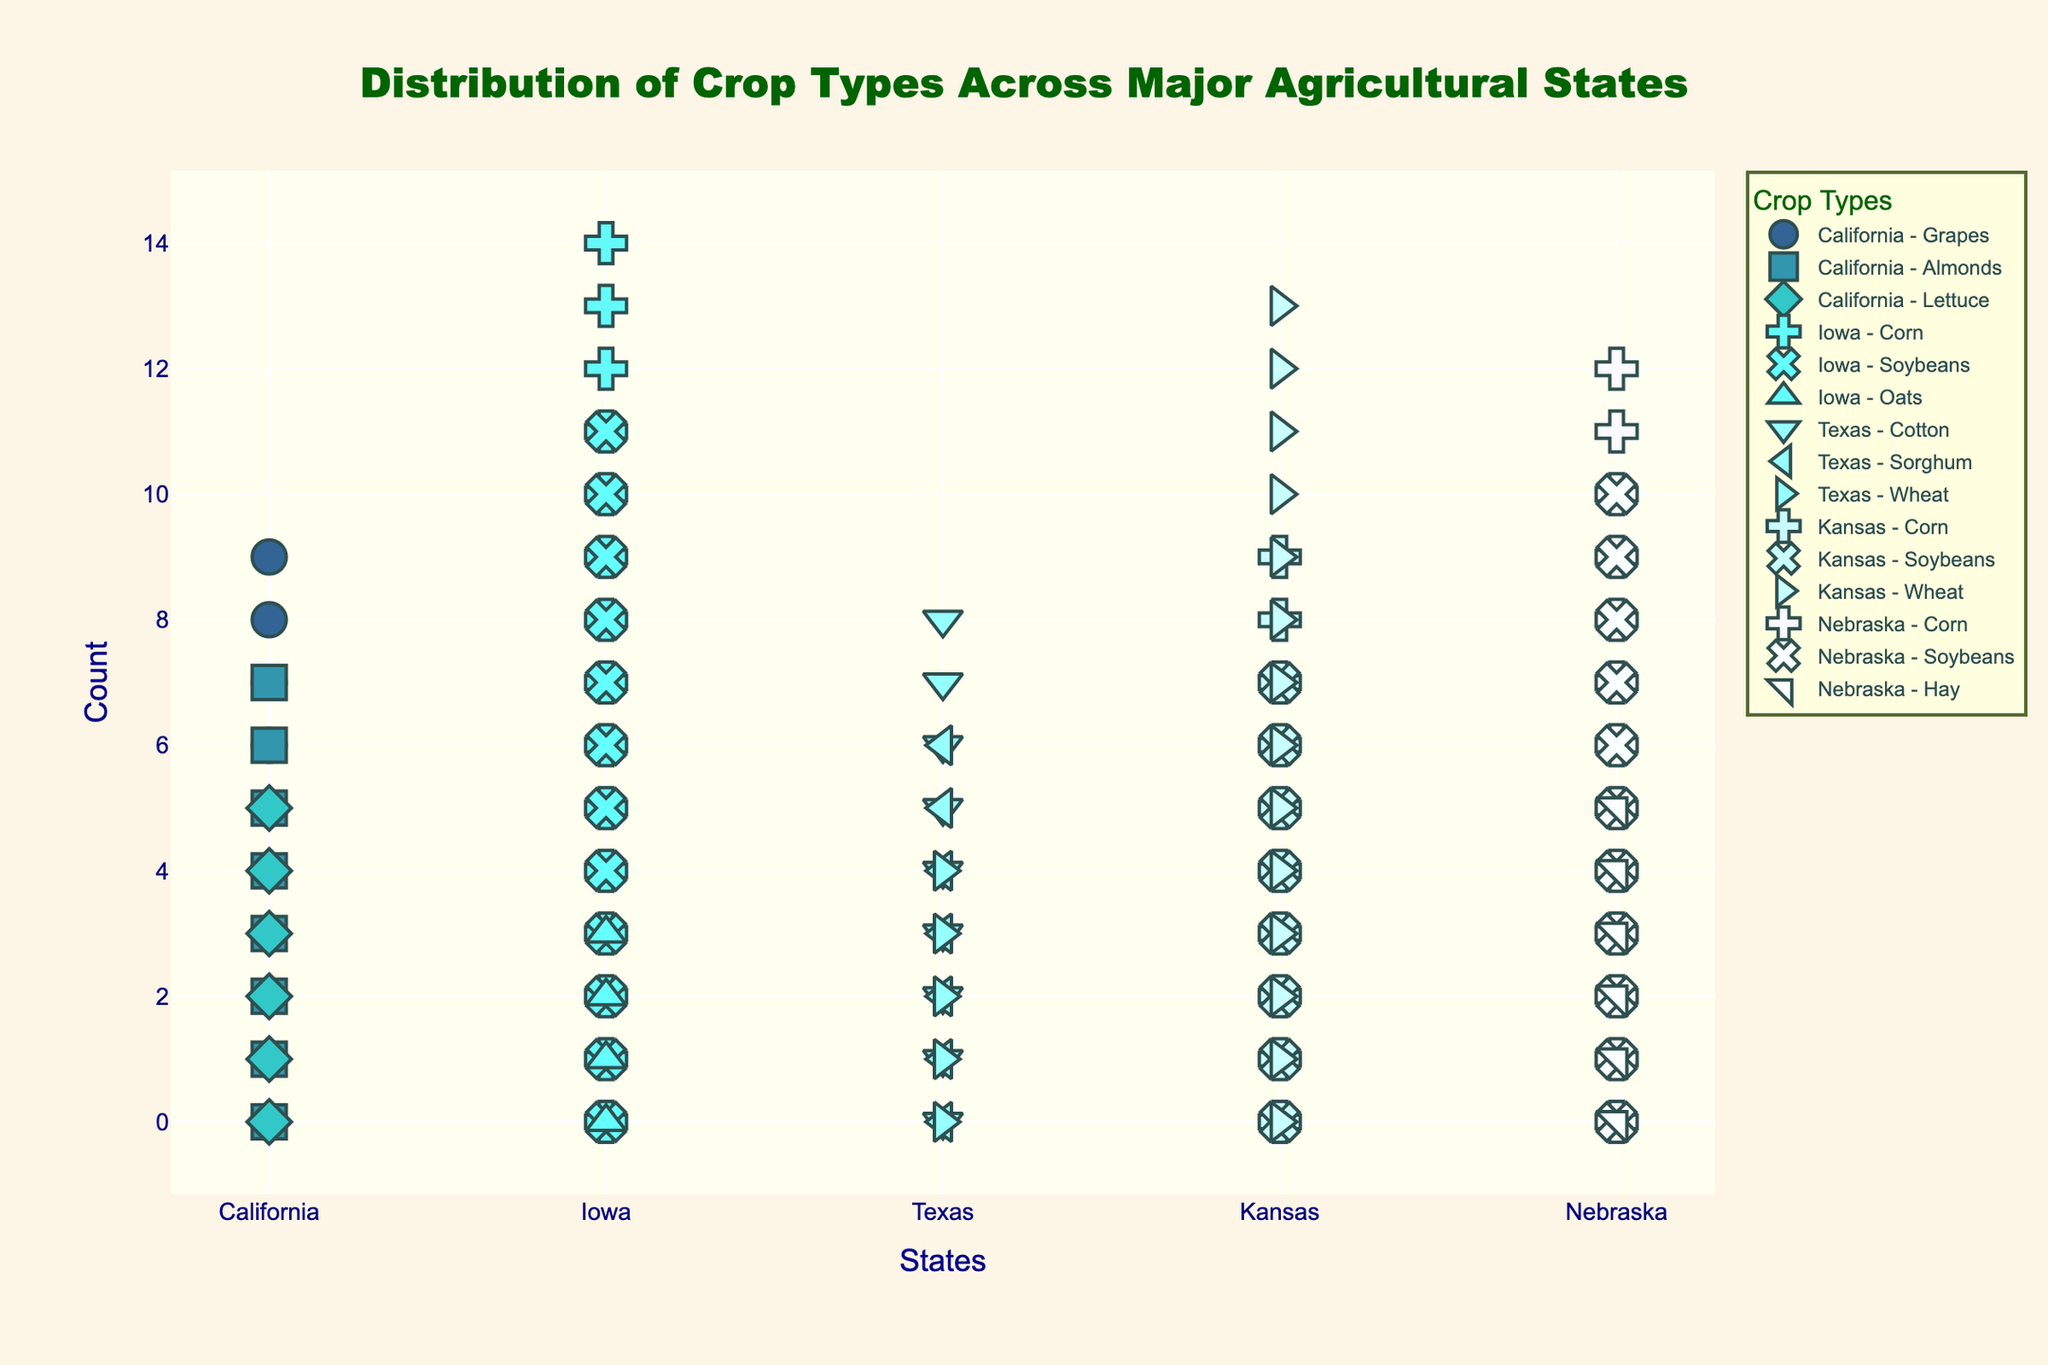what is the title of the plot? The title is located at the top of the plot and is usually the largest text in the figure. It gives a brief description of what the plot is about.
Answer: Distribution of Crop Types Across Major Agricultural States which state has the highest total crop count? To determine the state with the highest total crop count, sum the counts for all crops within each state and compare. California (10+8+6 = 24), Iowa (15+12+4 = 31), Texas (9+7+5 = 21), Kansas (14+10+8 = 32), Nebraska (13+11+6 = 30).
Answer: Kansas how many different crop types are present in Texas? Count the different crops listed under Texas in the plot legend and within the plot itself.
Answer: 3 which crop is most common in Iowa? Find the crop with the highest count for Iowa by looking at the number of markers representing each crop in Iowa. Corn has 15 markers, Soybeans 12, and Oats 4, therefore, Corn is the most common.
Answer: Corn is there any state that grows both Corn and Soybeans? Check each state's crops to see if both Corn and Soybeans are present. Iowa (Yes), Kansas (Yes), Nebraska (Yes).
Answer: Yes compare the count of Wheat in Texas and Kansas. Find and compare the number of Wheat markers in Texas and Kansas from the plot. Texas has 5 and Kansas has 14.
Answer: Kansas has more Wheat than Texas what is the combined crop count for Grapes and Almonds in California? Add the counts of Grapes and Almonds in California. Grapes have 10 and Almonds have 8. So, 10 + 8.
Answer: 18 how many states grow more than one type of crop? Count the states where more than one type of crop is represented. All five states (California, Iowa, Texas, Kansas, Nebraska) grow more than one type of crop.
Answer: 5 what crop appears in both Kansas and Nebraska? Identify the common crops between Kansas and Nebraska by looking at the crops grown in each state. Both states grow Corn and Soybeans.
Answer: Corn and Soybeans does any state grow Lettuce? Check if Lettuce is listed as a crop for any state by looking at the crops in the plot.
Answer: California 